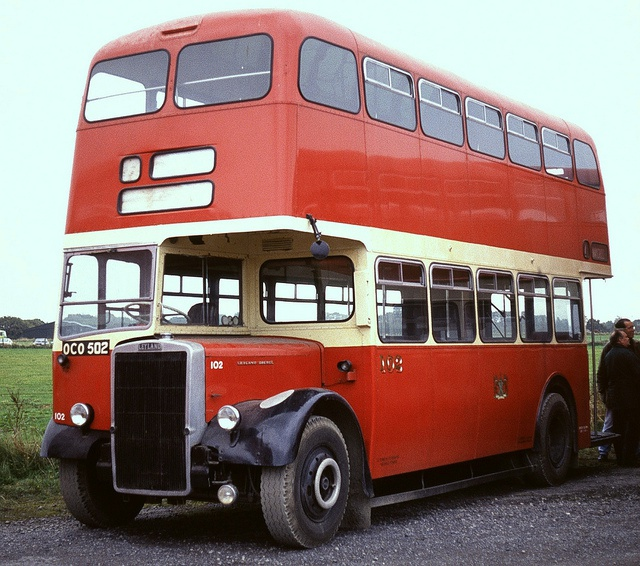Describe the objects in this image and their specific colors. I can see bus in ivory, black, brown, and salmon tones, people in ivory, black, maroon, gray, and brown tones, people in ivory, black, maroon, and gray tones, and car in ivory, darkgray, lightgray, and gray tones in this image. 